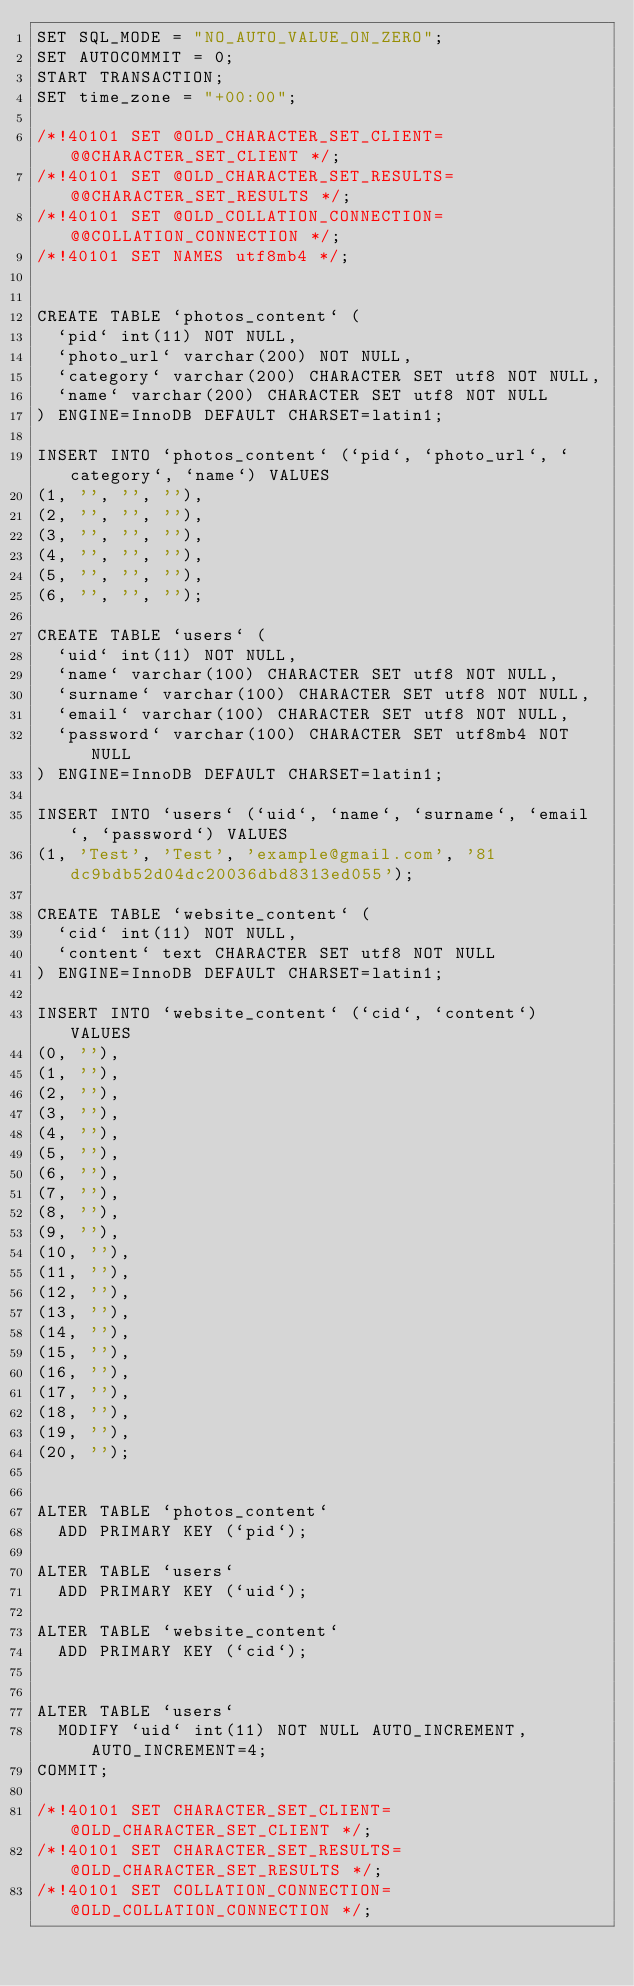Convert code to text. <code><loc_0><loc_0><loc_500><loc_500><_SQL_>SET SQL_MODE = "NO_AUTO_VALUE_ON_ZERO";
SET AUTOCOMMIT = 0;
START TRANSACTION;
SET time_zone = "+00:00";

/*!40101 SET @OLD_CHARACTER_SET_CLIENT=@@CHARACTER_SET_CLIENT */;
/*!40101 SET @OLD_CHARACTER_SET_RESULTS=@@CHARACTER_SET_RESULTS */;
/*!40101 SET @OLD_COLLATION_CONNECTION=@@COLLATION_CONNECTION */;
/*!40101 SET NAMES utf8mb4 */;


CREATE TABLE `photos_content` (
  `pid` int(11) NOT NULL,
  `photo_url` varchar(200) NOT NULL,
  `category` varchar(200) CHARACTER SET utf8 NOT NULL,
  `name` varchar(200) CHARACTER SET utf8 NOT NULL
) ENGINE=InnoDB DEFAULT CHARSET=latin1;

INSERT INTO `photos_content` (`pid`, `photo_url`, `category`, `name`) VALUES
(1, '', '', ''),
(2, '', '', ''),
(3, '', '', ''),
(4, '', '', ''),
(5, '', '', ''),
(6, '', '', '');

CREATE TABLE `users` (
  `uid` int(11) NOT NULL,
  `name` varchar(100) CHARACTER SET utf8 NOT NULL,
  `surname` varchar(100) CHARACTER SET utf8 NOT NULL,
  `email` varchar(100) CHARACTER SET utf8 NOT NULL,
  `password` varchar(100) CHARACTER SET utf8mb4 NOT NULL
) ENGINE=InnoDB DEFAULT CHARSET=latin1;

INSERT INTO `users` (`uid`, `name`, `surname`, `email`, `password`) VALUES
(1, 'Test', 'Test', 'example@gmail.com', '81dc9bdb52d04dc20036dbd8313ed055');

CREATE TABLE `website_content` (
  `cid` int(11) NOT NULL,
  `content` text CHARACTER SET utf8 NOT NULL
) ENGINE=InnoDB DEFAULT CHARSET=latin1;

INSERT INTO `website_content` (`cid`, `content`) VALUES
(0, ''),
(1, ''),
(2, ''),
(3, ''),
(4, ''),
(5, ''),
(6, ''),
(7, ''),
(8, ''),
(9, ''),
(10, ''),
(11, ''),
(12, ''),
(13, ''),
(14, ''),
(15, ''),
(16, ''),
(17, ''),
(18, ''),
(19, ''),
(20, '');


ALTER TABLE `photos_content`
  ADD PRIMARY KEY (`pid`);

ALTER TABLE `users`
  ADD PRIMARY KEY (`uid`);

ALTER TABLE `website_content`
  ADD PRIMARY KEY (`cid`);


ALTER TABLE `users`
  MODIFY `uid` int(11) NOT NULL AUTO_INCREMENT, AUTO_INCREMENT=4;
COMMIT;

/*!40101 SET CHARACTER_SET_CLIENT=@OLD_CHARACTER_SET_CLIENT */;
/*!40101 SET CHARACTER_SET_RESULTS=@OLD_CHARACTER_SET_RESULTS */;
/*!40101 SET COLLATION_CONNECTION=@OLD_COLLATION_CONNECTION */;
</code> 